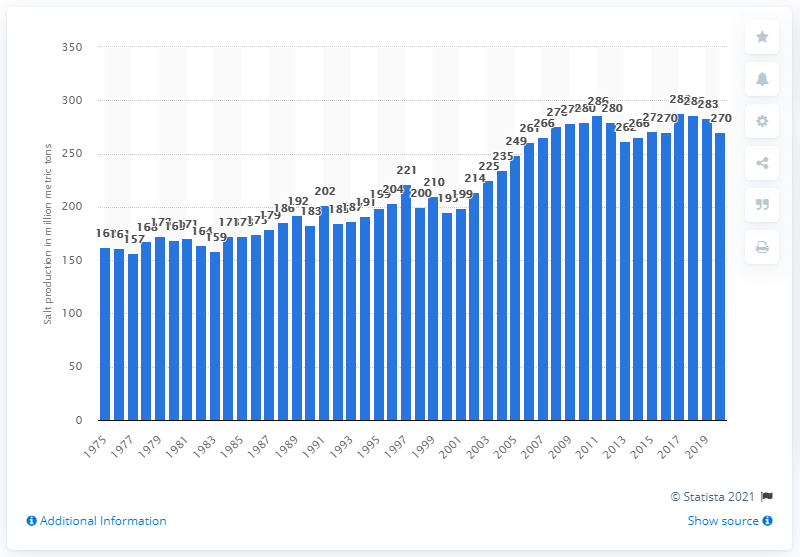Identify some key points in this picture. In 2020, the global production of salt was 270 million metric tons. 